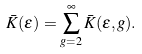Convert formula to latex. <formula><loc_0><loc_0><loc_500><loc_500>\bar { K } ( \epsilon ) = \sum _ { g = 2 } ^ { \infty } \bar { K } ( \epsilon , g ) .</formula> 